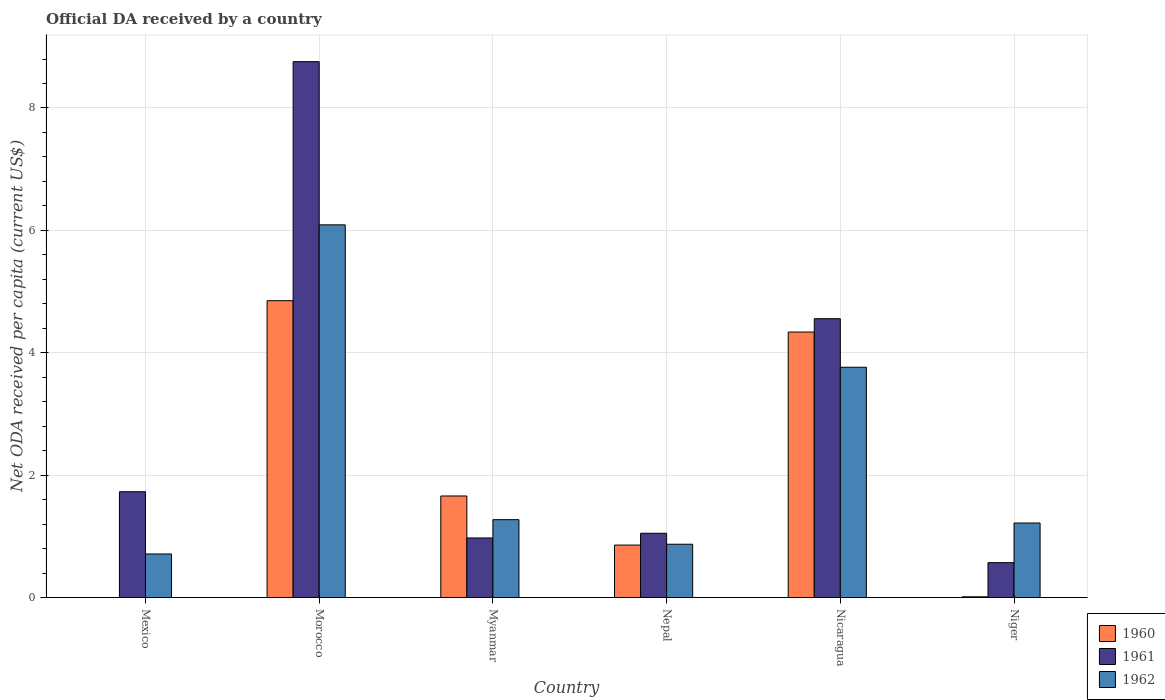How many different coloured bars are there?
Your response must be concise. 3. How many groups of bars are there?
Your response must be concise. 6. Are the number of bars on each tick of the X-axis equal?
Offer a terse response. No. How many bars are there on the 4th tick from the left?
Offer a very short reply. 3. What is the label of the 6th group of bars from the left?
Your answer should be very brief. Niger. In how many cases, is the number of bars for a given country not equal to the number of legend labels?
Provide a succinct answer. 1. What is the ODA received in in 1962 in Morocco?
Provide a short and direct response. 6.09. Across all countries, what is the maximum ODA received in in 1960?
Ensure brevity in your answer.  4.85. In which country was the ODA received in in 1962 maximum?
Offer a terse response. Morocco. What is the total ODA received in in 1962 in the graph?
Ensure brevity in your answer.  13.93. What is the difference between the ODA received in in 1961 in Morocco and that in Myanmar?
Ensure brevity in your answer.  7.78. What is the difference between the ODA received in in 1961 in Mexico and the ODA received in in 1962 in Nicaragua?
Your answer should be compact. -2.03. What is the average ODA received in in 1961 per country?
Keep it short and to the point. 2.94. What is the difference between the ODA received in of/in 1962 and ODA received in of/in 1960 in Myanmar?
Provide a short and direct response. -0.39. What is the ratio of the ODA received in in 1962 in Mexico to that in Morocco?
Keep it short and to the point. 0.12. Is the difference between the ODA received in in 1962 in Nicaragua and Niger greater than the difference between the ODA received in in 1960 in Nicaragua and Niger?
Your answer should be very brief. No. What is the difference between the highest and the second highest ODA received in in 1962?
Keep it short and to the point. -2.49. What is the difference between the highest and the lowest ODA received in in 1960?
Keep it short and to the point. 4.85. Is it the case that in every country, the sum of the ODA received in in 1962 and ODA received in in 1961 is greater than the ODA received in in 1960?
Your response must be concise. Yes. How many countries are there in the graph?
Your answer should be very brief. 6. What is the difference between two consecutive major ticks on the Y-axis?
Ensure brevity in your answer.  2. Does the graph contain grids?
Make the answer very short. Yes. Where does the legend appear in the graph?
Ensure brevity in your answer.  Bottom right. How many legend labels are there?
Ensure brevity in your answer.  3. What is the title of the graph?
Your answer should be very brief. Official DA received by a country. What is the label or title of the X-axis?
Your answer should be compact. Country. What is the label or title of the Y-axis?
Provide a succinct answer. Net ODA received per capita (current US$). What is the Net ODA received per capita (current US$) of 1960 in Mexico?
Your response must be concise. 0. What is the Net ODA received per capita (current US$) of 1961 in Mexico?
Provide a succinct answer. 1.73. What is the Net ODA received per capita (current US$) in 1962 in Mexico?
Ensure brevity in your answer.  0.71. What is the Net ODA received per capita (current US$) in 1960 in Morocco?
Your response must be concise. 4.85. What is the Net ODA received per capita (current US$) of 1961 in Morocco?
Provide a succinct answer. 8.76. What is the Net ODA received per capita (current US$) of 1962 in Morocco?
Your answer should be compact. 6.09. What is the Net ODA received per capita (current US$) in 1960 in Myanmar?
Your answer should be compact. 1.66. What is the Net ODA received per capita (current US$) of 1961 in Myanmar?
Make the answer very short. 0.97. What is the Net ODA received per capita (current US$) in 1962 in Myanmar?
Give a very brief answer. 1.27. What is the Net ODA received per capita (current US$) in 1960 in Nepal?
Give a very brief answer. 0.86. What is the Net ODA received per capita (current US$) in 1961 in Nepal?
Make the answer very short. 1.05. What is the Net ODA received per capita (current US$) in 1962 in Nepal?
Provide a succinct answer. 0.87. What is the Net ODA received per capita (current US$) in 1960 in Nicaragua?
Make the answer very short. 4.34. What is the Net ODA received per capita (current US$) of 1961 in Nicaragua?
Offer a very short reply. 4.56. What is the Net ODA received per capita (current US$) of 1962 in Nicaragua?
Offer a terse response. 3.76. What is the Net ODA received per capita (current US$) in 1960 in Niger?
Provide a succinct answer. 0.01. What is the Net ODA received per capita (current US$) of 1961 in Niger?
Keep it short and to the point. 0.57. What is the Net ODA received per capita (current US$) of 1962 in Niger?
Give a very brief answer. 1.22. Across all countries, what is the maximum Net ODA received per capita (current US$) of 1960?
Offer a terse response. 4.85. Across all countries, what is the maximum Net ODA received per capita (current US$) in 1961?
Make the answer very short. 8.76. Across all countries, what is the maximum Net ODA received per capita (current US$) of 1962?
Your response must be concise. 6.09. Across all countries, what is the minimum Net ODA received per capita (current US$) in 1960?
Your answer should be compact. 0. Across all countries, what is the minimum Net ODA received per capita (current US$) in 1961?
Provide a succinct answer. 0.57. Across all countries, what is the minimum Net ODA received per capita (current US$) of 1962?
Your response must be concise. 0.71. What is the total Net ODA received per capita (current US$) in 1960 in the graph?
Keep it short and to the point. 11.72. What is the total Net ODA received per capita (current US$) in 1961 in the graph?
Offer a very short reply. 17.64. What is the total Net ODA received per capita (current US$) of 1962 in the graph?
Offer a very short reply. 13.93. What is the difference between the Net ODA received per capita (current US$) of 1961 in Mexico and that in Morocco?
Give a very brief answer. -7.03. What is the difference between the Net ODA received per capita (current US$) of 1962 in Mexico and that in Morocco?
Provide a short and direct response. -5.38. What is the difference between the Net ODA received per capita (current US$) in 1961 in Mexico and that in Myanmar?
Make the answer very short. 0.76. What is the difference between the Net ODA received per capita (current US$) in 1962 in Mexico and that in Myanmar?
Give a very brief answer. -0.56. What is the difference between the Net ODA received per capita (current US$) of 1961 in Mexico and that in Nepal?
Ensure brevity in your answer.  0.68. What is the difference between the Net ODA received per capita (current US$) of 1962 in Mexico and that in Nepal?
Offer a very short reply. -0.16. What is the difference between the Net ODA received per capita (current US$) of 1961 in Mexico and that in Nicaragua?
Provide a succinct answer. -2.83. What is the difference between the Net ODA received per capita (current US$) of 1962 in Mexico and that in Nicaragua?
Offer a terse response. -3.05. What is the difference between the Net ODA received per capita (current US$) in 1961 in Mexico and that in Niger?
Provide a succinct answer. 1.16. What is the difference between the Net ODA received per capita (current US$) of 1962 in Mexico and that in Niger?
Your response must be concise. -0.51. What is the difference between the Net ODA received per capita (current US$) of 1960 in Morocco and that in Myanmar?
Your answer should be very brief. 3.19. What is the difference between the Net ODA received per capita (current US$) in 1961 in Morocco and that in Myanmar?
Give a very brief answer. 7.78. What is the difference between the Net ODA received per capita (current US$) of 1962 in Morocco and that in Myanmar?
Provide a short and direct response. 4.82. What is the difference between the Net ODA received per capita (current US$) of 1960 in Morocco and that in Nepal?
Offer a terse response. 3.99. What is the difference between the Net ODA received per capita (current US$) of 1961 in Morocco and that in Nepal?
Your answer should be compact. 7.71. What is the difference between the Net ODA received per capita (current US$) of 1962 in Morocco and that in Nepal?
Give a very brief answer. 5.22. What is the difference between the Net ODA received per capita (current US$) of 1960 in Morocco and that in Nicaragua?
Keep it short and to the point. 0.51. What is the difference between the Net ODA received per capita (current US$) in 1961 in Morocco and that in Nicaragua?
Ensure brevity in your answer.  4.2. What is the difference between the Net ODA received per capita (current US$) of 1962 in Morocco and that in Nicaragua?
Give a very brief answer. 2.33. What is the difference between the Net ODA received per capita (current US$) of 1960 in Morocco and that in Niger?
Your answer should be compact. 4.84. What is the difference between the Net ODA received per capita (current US$) of 1961 in Morocco and that in Niger?
Provide a short and direct response. 8.19. What is the difference between the Net ODA received per capita (current US$) of 1962 in Morocco and that in Niger?
Provide a succinct answer. 4.87. What is the difference between the Net ODA received per capita (current US$) in 1960 in Myanmar and that in Nepal?
Your answer should be very brief. 0.8. What is the difference between the Net ODA received per capita (current US$) in 1961 in Myanmar and that in Nepal?
Your answer should be compact. -0.08. What is the difference between the Net ODA received per capita (current US$) of 1962 in Myanmar and that in Nepal?
Provide a short and direct response. 0.4. What is the difference between the Net ODA received per capita (current US$) of 1960 in Myanmar and that in Nicaragua?
Your answer should be compact. -2.68. What is the difference between the Net ODA received per capita (current US$) of 1961 in Myanmar and that in Nicaragua?
Provide a short and direct response. -3.58. What is the difference between the Net ODA received per capita (current US$) in 1962 in Myanmar and that in Nicaragua?
Your response must be concise. -2.49. What is the difference between the Net ODA received per capita (current US$) in 1960 in Myanmar and that in Niger?
Ensure brevity in your answer.  1.65. What is the difference between the Net ODA received per capita (current US$) in 1961 in Myanmar and that in Niger?
Give a very brief answer. 0.4. What is the difference between the Net ODA received per capita (current US$) in 1962 in Myanmar and that in Niger?
Make the answer very short. 0.05. What is the difference between the Net ODA received per capita (current US$) of 1960 in Nepal and that in Nicaragua?
Ensure brevity in your answer.  -3.48. What is the difference between the Net ODA received per capita (current US$) of 1961 in Nepal and that in Nicaragua?
Give a very brief answer. -3.51. What is the difference between the Net ODA received per capita (current US$) of 1962 in Nepal and that in Nicaragua?
Provide a succinct answer. -2.89. What is the difference between the Net ODA received per capita (current US$) in 1960 in Nepal and that in Niger?
Provide a succinct answer. 0.85. What is the difference between the Net ODA received per capita (current US$) in 1961 in Nepal and that in Niger?
Keep it short and to the point. 0.48. What is the difference between the Net ODA received per capita (current US$) of 1962 in Nepal and that in Niger?
Your answer should be compact. -0.35. What is the difference between the Net ODA received per capita (current US$) in 1960 in Nicaragua and that in Niger?
Provide a succinct answer. 4.33. What is the difference between the Net ODA received per capita (current US$) in 1961 in Nicaragua and that in Niger?
Your response must be concise. 3.99. What is the difference between the Net ODA received per capita (current US$) of 1962 in Nicaragua and that in Niger?
Provide a short and direct response. 2.55. What is the difference between the Net ODA received per capita (current US$) of 1961 in Mexico and the Net ODA received per capita (current US$) of 1962 in Morocco?
Offer a terse response. -4.36. What is the difference between the Net ODA received per capita (current US$) in 1961 in Mexico and the Net ODA received per capita (current US$) in 1962 in Myanmar?
Your response must be concise. 0.46. What is the difference between the Net ODA received per capita (current US$) in 1961 in Mexico and the Net ODA received per capita (current US$) in 1962 in Nepal?
Offer a very short reply. 0.86. What is the difference between the Net ODA received per capita (current US$) of 1961 in Mexico and the Net ODA received per capita (current US$) of 1962 in Nicaragua?
Provide a short and direct response. -2.03. What is the difference between the Net ODA received per capita (current US$) in 1961 in Mexico and the Net ODA received per capita (current US$) in 1962 in Niger?
Offer a very short reply. 0.51. What is the difference between the Net ODA received per capita (current US$) of 1960 in Morocco and the Net ODA received per capita (current US$) of 1961 in Myanmar?
Make the answer very short. 3.88. What is the difference between the Net ODA received per capita (current US$) in 1960 in Morocco and the Net ODA received per capita (current US$) in 1962 in Myanmar?
Offer a very short reply. 3.58. What is the difference between the Net ODA received per capita (current US$) in 1961 in Morocco and the Net ODA received per capita (current US$) in 1962 in Myanmar?
Your response must be concise. 7.48. What is the difference between the Net ODA received per capita (current US$) of 1960 in Morocco and the Net ODA received per capita (current US$) of 1961 in Nepal?
Offer a very short reply. 3.8. What is the difference between the Net ODA received per capita (current US$) in 1960 in Morocco and the Net ODA received per capita (current US$) in 1962 in Nepal?
Provide a short and direct response. 3.98. What is the difference between the Net ODA received per capita (current US$) of 1961 in Morocco and the Net ODA received per capita (current US$) of 1962 in Nepal?
Make the answer very short. 7.89. What is the difference between the Net ODA received per capita (current US$) of 1960 in Morocco and the Net ODA received per capita (current US$) of 1961 in Nicaragua?
Keep it short and to the point. 0.29. What is the difference between the Net ODA received per capita (current US$) of 1960 in Morocco and the Net ODA received per capita (current US$) of 1962 in Nicaragua?
Make the answer very short. 1.09. What is the difference between the Net ODA received per capita (current US$) of 1961 in Morocco and the Net ODA received per capita (current US$) of 1962 in Nicaragua?
Your response must be concise. 4.99. What is the difference between the Net ODA received per capita (current US$) of 1960 in Morocco and the Net ODA received per capita (current US$) of 1961 in Niger?
Your response must be concise. 4.28. What is the difference between the Net ODA received per capita (current US$) in 1960 in Morocco and the Net ODA received per capita (current US$) in 1962 in Niger?
Offer a very short reply. 3.63. What is the difference between the Net ODA received per capita (current US$) of 1961 in Morocco and the Net ODA received per capita (current US$) of 1962 in Niger?
Provide a short and direct response. 7.54. What is the difference between the Net ODA received per capita (current US$) of 1960 in Myanmar and the Net ODA received per capita (current US$) of 1961 in Nepal?
Provide a succinct answer. 0.61. What is the difference between the Net ODA received per capita (current US$) of 1960 in Myanmar and the Net ODA received per capita (current US$) of 1962 in Nepal?
Provide a succinct answer. 0.79. What is the difference between the Net ODA received per capita (current US$) of 1961 in Myanmar and the Net ODA received per capita (current US$) of 1962 in Nepal?
Ensure brevity in your answer.  0.1. What is the difference between the Net ODA received per capita (current US$) in 1960 in Myanmar and the Net ODA received per capita (current US$) in 1961 in Nicaragua?
Make the answer very short. -2.9. What is the difference between the Net ODA received per capita (current US$) of 1960 in Myanmar and the Net ODA received per capita (current US$) of 1962 in Nicaragua?
Provide a succinct answer. -2.1. What is the difference between the Net ODA received per capita (current US$) of 1961 in Myanmar and the Net ODA received per capita (current US$) of 1962 in Nicaragua?
Offer a very short reply. -2.79. What is the difference between the Net ODA received per capita (current US$) of 1960 in Myanmar and the Net ODA received per capita (current US$) of 1961 in Niger?
Your response must be concise. 1.09. What is the difference between the Net ODA received per capita (current US$) of 1960 in Myanmar and the Net ODA received per capita (current US$) of 1962 in Niger?
Offer a terse response. 0.44. What is the difference between the Net ODA received per capita (current US$) in 1961 in Myanmar and the Net ODA received per capita (current US$) in 1962 in Niger?
Give a very brief answer. -0.24. What is the difference between the Net ODA received per capita (current US$) of 1960 in Nepal and the Net ODA received per capita (current US$) of 1961 in Nicaragua?
Provide a short and direct response. -3.7. What is the difference between the Net ODA received per capita (current US$) of 1960 in Nepal and the Net ODA received per capita (current US$) of 1962 in Nicaragua?
Ensure brevity in your answer.  -2.91. What is the difference between the Net ODA received per capita (current US$) of 1961 in Nepal and the Net ODA received per capita (current US$) of 1962 in Nicaragua?
Provide a succinct answer. -2.71. What is the difference between the Net ODA received per capita (current US$) of 1960 in Nepal and the Net ODA received per capita (current US$) of 1961 in Niger?
Give a very brief answer. 0.29. What is the difference between the Net ODA received per capita (current US$) of 1960 in Nepal and the Net ODA received per capita (current US$) of 1962 in Niger?
Provide a succinct answer. -0.36. What is the difference between the Net ODA received per capita (current US$) in 1961 in Nepal and the Net ODA received per capita (current US$) in 1962 in Niger?
Your response must be concise. -0.17. What is the difference between the Net ODA received per capita (current US$) in 1960 in Nicaragua and the Net ODA received per capita (current US$) in 1961 in Niger?
Offer a terse response. 3.77. What is the difference between the Net ODA received per capita (current US$) in 1960 in Nicaragua and the Net ODA received per capita (current US$) in 1962 in Niger?
Keep it short and to the point. 3.12. What is the difference between the Net ODA received per capita (current US$) in 1961 in Nicaragua and the Net ODA received per capita (current US$) in 1962 in Niger?
Provide a short and direct response. 3.34. What is the average Net ODA received per capita (current US$) in 1960 per country?
Your answer should be very brief. 1.95. What is the average Net ODA received per capita (current US$) of 1961 per country?
Offer a terse response. 2.94. What is the average Net ODA received per capita (current US$) in 1962 per country?
Ensure brevity in your answer.  2.32. What is the difference between the Net ODA received per capita (current US$) in 1961 and Net ODA received per capita (current US$) in 1962 in Mexico?
Provide a succinct answer. 1.02. What is the difference between the Net ODA received per capita (current US$) in 1960 and Net ODA received per capita (current US$) in 1961 in Morocco?
Provide a succinct answer. -3.91. What is the difference between the Net ODA received per capita (current US$) in 1960 and Net ODA received per capita (current US$) in 1962 in Morocco?
Offer a terse response. -1.24. What is the difference between the Net ODA received per capita (current US$) of 1961 and Net ODA received per capita (current US$) of 1962 in Morocco?
Provide a short and direct response. 2.67. What is the difference between the Net ODA received per capita (current US$) of 1960 and Net ODA received per capita (current US$) of 1961 in Myanmar?
Make the answer very short. 0.69. What is the difference between the Net ODA received per capita (current US$) of 1960 and Net ODA received per capita (current US$) of 1962 in Myanmar?
Ensure brevity in your answer.  0.39. What is the difference between the Net ODA received per capita (current US$) in 1961 and Net ODA received per capita (current US$) in 1962 in Myanmar?
Make the answer very short. -0.3. What is the difference between the Net ODA received per capita (current US$) of 1960 and Net ODA received per capita (current US$) of 1961 in Nepal?
Offer a very short reply. -0.19. What is the difference between the Net ODA received per capita (current US$) in 1960 and Net ODA received per capita (current US$) in 1962 in Nepal?
Make the answer very short. -0.01. What is the difference between the Net ODA received per capita (current US$) in 1961 and Net ODA received per capita (current US$) in 1962 in Nepal?
Offer a very short reply. 0.18. What is the difference between the Net ODA received per capita (current US$) in 1960 and Net ODA received per capita (current US$) in 1961 in Nicaragua?
Your answer should be compact. -0.22. What is the difference between the Net ODA received per capita (current US$) of 1960 and Net ODA received per capita (current US$) of 1962 in Nicaragua?
Make the answer very short. 0.58. What is the difference between the Net ODA received per capita (current US$) in 1961 and Net ODA received per capita (current US$) in 1962 in Nicaragua?
Offer a terse response. 0.79. What is the difference between the Net ODA received per capita (current US$) of 1960 and Net ODA received per capita (current US$) of 1961 in Niger?
Provide a succinct answer. -0.56. What is the difference between the Net ODA received per capita (current US$) of 1960 and Net ODA received per capita (current US$) of 1962 in Niger?
Your answer should be compact. -1.21. What is the difference between the Net ODA received per capita (current US$) in 1961 and Net ODA received per capita (current US$) in 1962 in Niger?
Offer a terse response. -0.65. What is the ratio of the Net ODA received per capita (current US$) in 1961 in Mexico to that in Morocco?
Your response must be concise. 0.2. What is the ratio of the Net ODA received per capita (current US$) in 1962 in Mexico to that in Morocco?
Offer a terse response. 0.12. What is the ratio of the Net ODA received per capita (current US$) in 1961 in Mexico to that in Myanmar?
Your answer should be compact. 1.78. What is the ratio of the Net ODA received per capita (current US$) of 1962 in Mexico to that in Myanmar?
Offer a very short reply. 0.56. What is the ratio of the Net ODA received per capita (current US$) in 1961 in Mexico to that in Nepal?
Your answer should be very brief. 1.65. What is the ratio of the Net ODA received per capita (current US$) in 1962 in Mexico to that in Nepal?
Keep it short and to the point. 0.82. What is the ratio of the Net ODA received per capita (current US$) in 1961 in Mexico to that in Nicaragua?
Make the answer very short. 0.38. What is the ratio of the Net ODA received per capita (current US$) of 1962 in Mexico to that in Nicaragua?
Ensure brevity in your answer.  0.19. What is the ratio of the Net ODA received per capita (current US$) of 1961 in Mexico to that in Niger?
Give a very brief answer. 3.04. What is the ratio of the Net ODA received per capita (current US$) in 1962 in Mexico to that in Niger?
Your answer should be compact. 0.58. What is the ratio of the Net ODA received per capita (current US$) of 1960 in Morocco to that in Myanmar?
Offer a very short reply. 2.92. What is the ratio of the Net ODA received per capita (current US$) of 1961 in Morocco to that in Myanmar?
Your response must be concise. 9. What is the ratio of the Net ODA received per capita (current US$) of 1962 in Morocco to that in Myanmar?
Provide a succinct answer. 4.79. What is the ratio of the Net ODA received per capita (current US$) in 1960 in Morocco to that in Nepal?
Keep it short and to the point. 5.66. What is the ratio of the Net ODA received per capita (current US$) in 1961 in Morocco to that in Nepal?
Your response must be concise. 8.34. What is the ratio of the Net ODA received per capita (current US$) of 1962 in Morocco to that in Nepal?
Your response must be concise. 6.99. What is the ratio of the Net ODA received per capita (current US$) in 1960 in Morocco to that in Nicaragua?
Your response must be concise. 1.12. What is the ratio of the Net ODA received per capita (current US$) of 1961 in Morocco to that in Nicaragua?
Your answer should be very brief. 1.92. What is the ratio of the Net ODA received per capita (current US$) of 1962 in Morocco to that in Nicaragua?
Ensure brevity in your answer.  1.62. What is the ratio of the Net ODA received per capita (current US$) in 1960 in Morocco to that in Niger?
Your answer should be compact. 411.71. What is the ratio of the Net ODA received per capita (current US$) of 1961 in Morocco to that in Niger?
Your response must be concise. 15.37. What is the ratio of the Net ODA received per capita (current US$) in 1962 in Morocco to that in Niger?
Keep it short and to the point. 5. What is the ratio of the Net ODA received per capita (current US$) of 1960 in Myanmar to that in Nepal?
Your response must be concise. 1.94. What is the ratio of the Net ODA received per capita (current US$) of 1961 in Myanmar to that in Nepal?
Offer a very short reply. 0.93. What is the ratio of the Net ODA received per capita (current US$) of 1962 in Myanmar to that in Nepal?
Provide a succinct answer. 1.46. What is the ratio of the Net ODA received per capita (current US$) of 1960 in Myanmar to that in Nicaragua?
Keep it short and to the point. 0.38. What is the ratio of the Net ODA received per capita (current US$) in 1961 in Myanmar to that in Nicaragua?
Ensure brevity in your answer.  0.21. What is the ratio of the Net ODA received per capita (current US$) of 1962 in Myanmar to that in Nicaragua?
Your response must be concise. 0.34. What is the ratio of the Net ODA received per capita (current US$) in 1960 in Myanmar to that in Niger?
Offer a terse response. 140.87. What is the ratio of the Net ODA received per capita (current US$) in 1961 in Myanmar to that in Niger?
Your answer should be very brief. 1.71. What is the ratio of the Net ODA received per capita (current US$) in 1962 in Myanmar to that in Niger?
Offer a terse response. 1.04. What is the ratio of the Net ODA received per capita (current US$) in 1960 in Nepal to that in Nicaragua?
Your answer should be very brief. 0.2. What is the ratio of the Net ODA received per capita (current US$) of 1961 in Nepal to that in Nicaragua?
Offer a very short reply. 0.23. What is the ratio of the Net ODA received per capita (current US$) in 1962 in Nepal to that in Nicaragua?
Ensure brevity in your answer.  0.23. What is the ratio of the Net ODA received per capita (current US$) in 1960 in Nepal to that in Niger?
Your response must be concise. 72.75. What is the ratio of the Net ODA received per capita (current US$) of 1961 in Nepal to that in Niger?
Keep it short and to the point. 1.84. What is the ratio of the Net ODA received per capita (current US$) in 1962 in Nepal to that in Niger?
Provide a succinct answer. 0.72. What is the ratio of the Net ODA received per capita (current US$) in 1960 in Nicaragua to that in Niger?
Provide a short and direct response. 368.28. What is the ratio of the Net ODA received per capita (current US$) of 1961 in Nicaragua to that in Niger?
Your answer should be compact. 8. What is the ratio of the Net ODA received per capita (current US$) in 1962 in Nicaragua to that in Niger?
Your answer should be very brief. 3.09. What is the difference between the highest and the second highest Net ODA received per capita (current US$) in 1960?
Provide a short and direct response. 0.51. What is the difference between the highest and the second highest Net ODA received per capita (current US$) in 1961?
Keep it short and to the point. 4.2. What is the difference between the highest and the second highest Net ODA received per capita (current US$) of 1962?
Offer a terse response. 2.33. What is the difference between the highest and the lowest Net ODA received per capita (current US$) of 1960?
Offer a very short reply. 4.85. What is the difference between the highest and the lowest Net ODA received per capita (current US$) of 1961?
Give a very brief answer. 8.19. What is the difference between the highest and the lowest Net ODA received per capita (current US$) in 1962?
Ensure brevity in your answer.  5.38. 